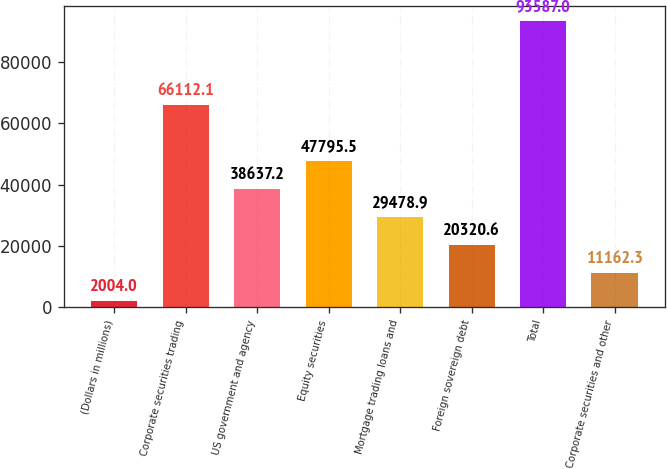Convert chart to OTSL. <chart><loc_0><loc_0><loc_500><loc_500><bar_chart><fcel>(Dollars in millions)<fcel>Corporate securities trading<fcel>US government and agency<fcel>Equity securities<fcel>Mortgage trading loans and<fcel>Foreign sovereign debt<fcel>Total<fcel>Corporate securities and other<nl><fcel>2004<fcel>66112.1<fcel>38637.2<fcel>47795.5<fcel>29478.9<fcel>20320.6<fcel>93587<fcel>11162.3<nl></chart> 